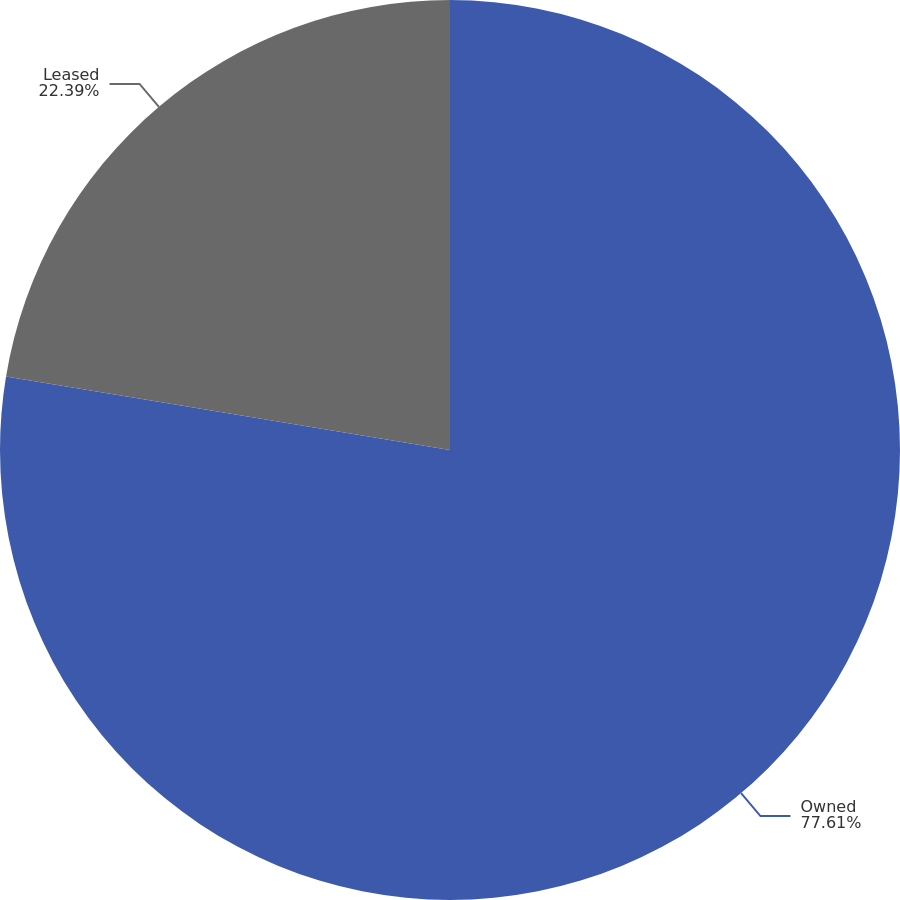Convert chart. <chart><loc_0><loc_0><loc_500><loc_500><pie_chart><fcel>Owned<fcel>Leased<nl><fcel>77.61%<fcel>22.39%<nl></chart> 